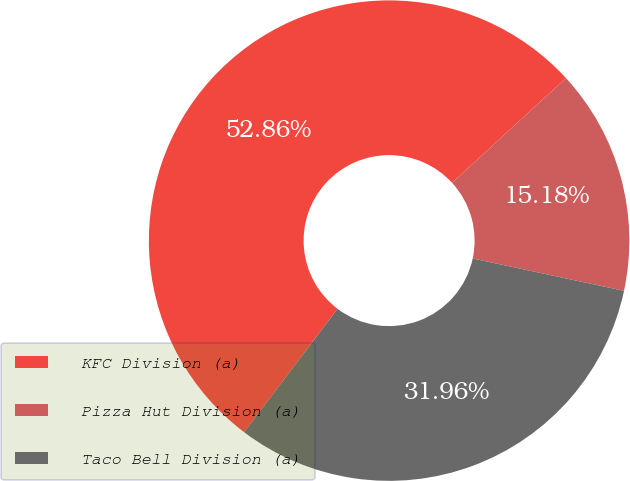Convert chart. <chart><loc_0><loc_0><loc_500><loc_500><pie_chart><fcel>KFC Division (a)<fcel>Pizza Hut Division (a)<fcel>Taco Bell Division (a)<nl><fcel>52.86%<fcel>15.18%<fcel>31.96%<nl></chart> 